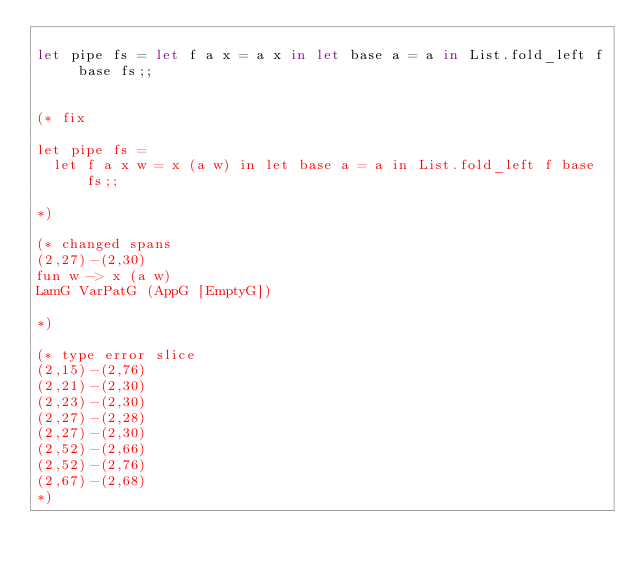Convert code to text. <code><loc_0><loc_0><loc_500><loc_500><_OCaml_>
let pipe fs = let f a x = a x in let base a = a in List.fold_left f base fs;;


(* fix

let pipe fs =
  let f a x w = x (a w) in let base a = a in List.fold_left f base fs;;

*)

(* changed spans
(2,27)-(2,30)
fun w -> x (a w)
LamG VarPatG (AppG [EmptyG])

*)

(* type error slice
(2,15)-(2,76)
(2,21)-(2,30)
(2,23)-(2,30)
(2,27)-(2,28)
(2,27)-(2,30)
(2,52)-(2,66)
(2,52)-(2,76)
(2,67)-(2,68)
*)
</code> 